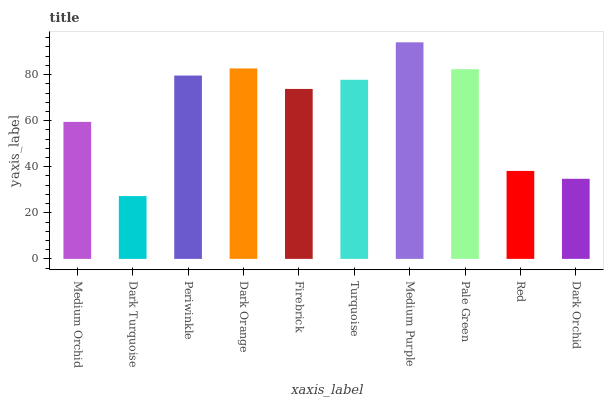Is Dark Turquoise the minimum?
Answer yes or no. Yes. Is Medium Purple the maximum?
Answer yes or no. Yes. Is Periwinkle the minimum?
Answer yes or no. No. Is Periwinkle the maximum?
Answer yes or no. No. Is Periwinkle greater than Dark Turquoise?
Answer yes or no. Yes. Is Dark Turquoise less than Periwinkle?
Answer yes or no. Yes. Is Dark Turquoise greater than Periwinkle?
Answer yes or no. No. Is Periwinkle less than Dark Turquoise?
Answer yes or no. No. Is Turquoise the high median?
Answer yes or no. Yes. Is Firebrick the low median?
Answer yes or no. Yes. Is Red the high median?
Answer yes or no. No. Is Medium Purple the low median?
Answer yes or no. No. 